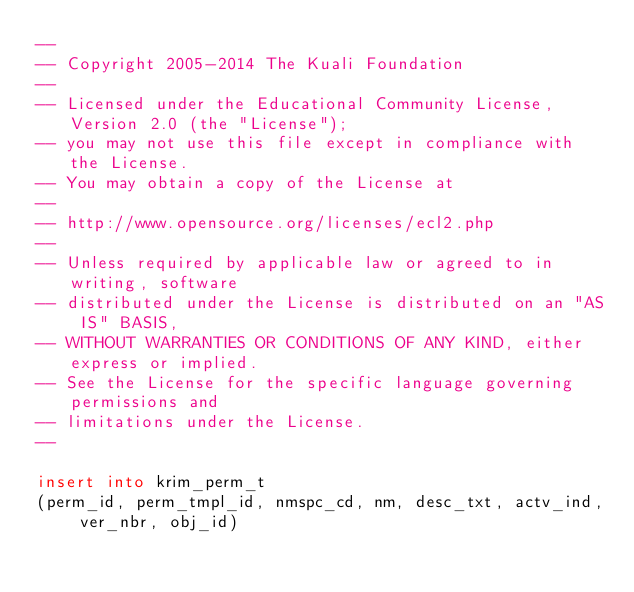<code> <loc_0><loc_0><loc_500><loc_500><_SQL_>--
-- Copyright 2005-2014 The Kuali Foundation
--
-- Licensed under the Educational Community License, Version 2.0 (the "License");
-- you may not use this file except in compliance with the License.
-- You may obtain a copy of the License at
--
-- http://www.opensource.org/licenses/ecl2.php
--
-- Unless required by applicable law or agreed to in writing, software
-- distributed under the License is distributed on an "AS IS" BASIS,
-- WITHOUT WARRANTIES OR CONDITIONS OF ANY KIND, either express or implied.
-- See the License for the specific language governing permissions and
-- limitations under the License.
--

insert into krim_perm_t
(perm_id, perm_tmpl_id, nmspc_cd, nm, desc_txt, actv_ind, ver_nbr, obj_id)</code> 